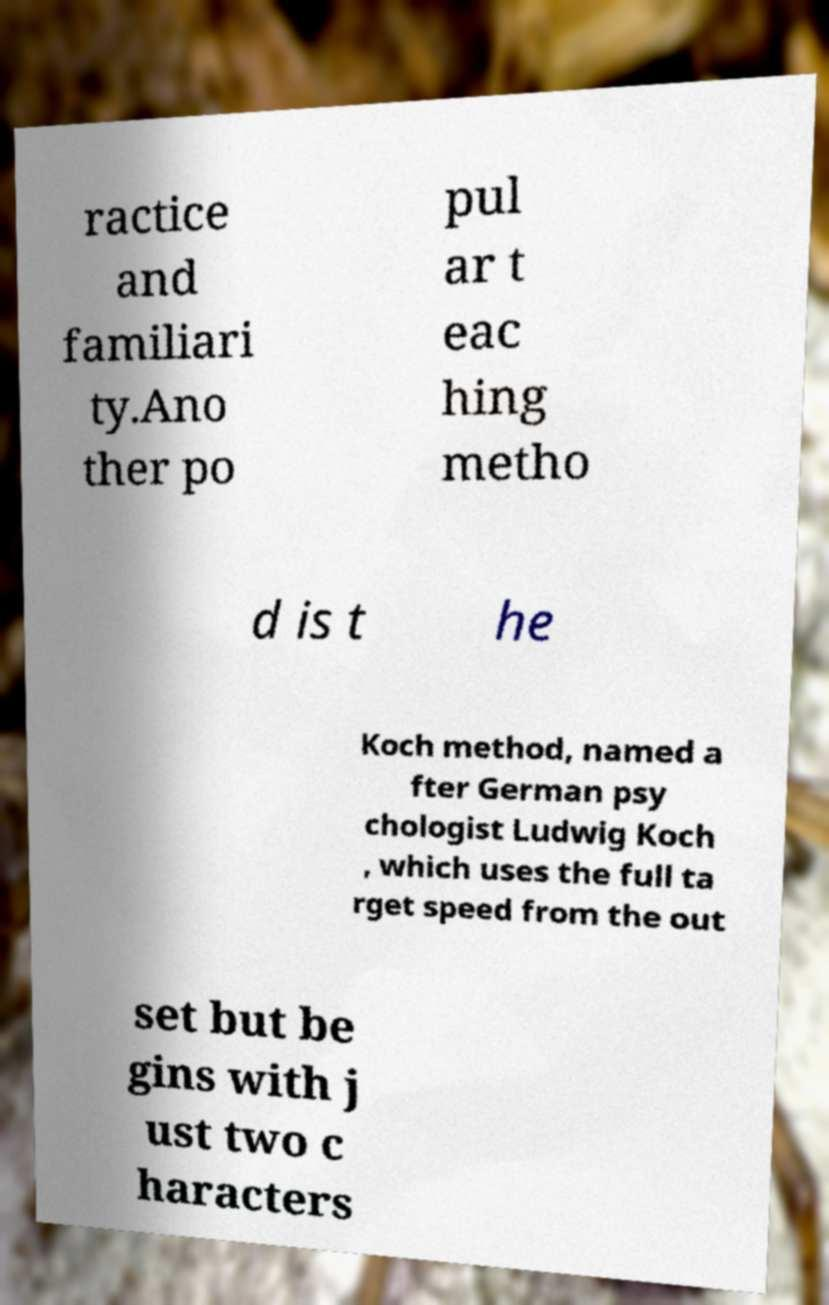For documentation purposes, I need the text within this image transcribed. Could you provide that? ractice and familiari ty.Ano ther po pul ar t eac hing metho d is t he Koch method, named a fter German psy chologist Ludwig Koch , which uses the full ta rget speed from the out set but be gins with j ust two c haracters 